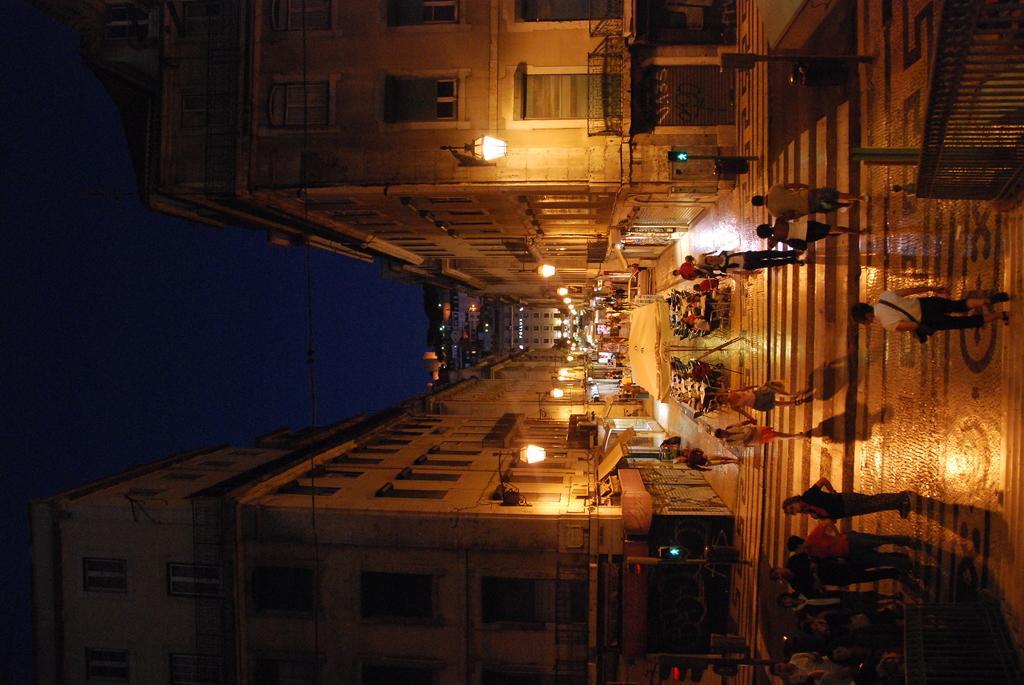Can you describe this image briefly? In the image we can see the buildings and these are the windows of the buildings. We can see there are even people walking and some of them are sitting, they are wearing clothes. Here we can see, fence, pole, light, footpath and the dark sky. 